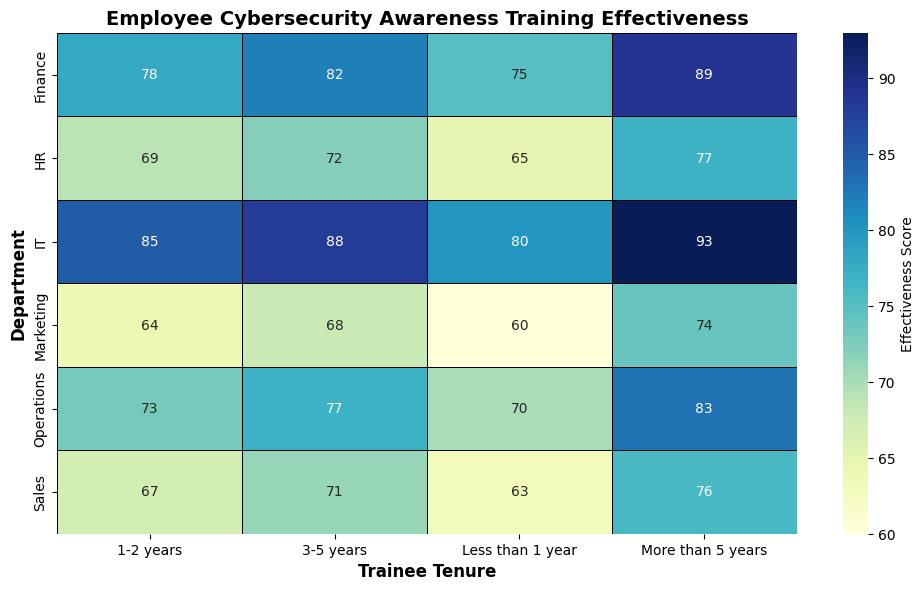Which department shows the highest overall effectiveness score? The highest overall effectiveness score is visible by identifying the darkest cell color in the chart. IT department employees with more than 5 years of tenure have the highest effectiveness score of 93.
Answer: IT What is the average effectiveness score for the HR department? To find the average effectiveness score for the HR department, sum the scores and divide by the number of scores: (65 + 69 + 72 + 77) / 4 = 283 / 4 = 70.75.
Answer: 70.75 How does the effectiveness score for less than 1-year trainees in Sales compare to those in Marketing? By comparing the cell colors and annotations, the effectiveness score for less than 1-year trainees in Sales is 63, and in Marketing, it is 60. Thus, the score is higher in Sales.
Answer: Sales (63) > Marketing (60) Which tenure level in the Operations department has the most significant increase in effectiveness compared to the previous tenure level? Observe the differences between consecutive tenure levels. The largest increase in the Operations department is from 3-5 years (77) to more than 5 years (83), an increase of 6 points.
Answer: More than 5 years Are there any departments with a uniform increase in scores as tenure increases? Look for a pattern where each consecutive tenure level has a higher score than the previous one. The IT and Finance departments show consistent increases across all tenure levels.
Answer: IT and Finance What is the total effectiveness score for all tenure levels in the Marketing department? Sum the effectiveness scores for each tenure level in the Marketing department: 60 + 64 + 68 + 74 = 266.
Answer: 266 Is there any department where the less than 1-year trainees score more than the 1-2 years trainees in any other department? Compare the effectiveness scores for less than 1-year trainees in all departments with the 1-2 years trainees in all other departments. IT less than 1 year (80) is higher than Operations 1-2 years (73).
Answer: Yes, IT vs Operations Which department shows the lowest effectiveness score across all tenure levels? Identify the lightest cell color in the chart. The marketing department has the lowest effectiveness score of 60 for less than 1-year trainees.
Answer: Marketing What is the combined effectiveness score for employees with more than 5 years of tenure in all departments? Sum the effectiveness scores for employees with more than 5 years of tenure across all departments: 89 (Finance) + 77 (HR) + 93 (IT) + 74 (Marketing) + 83 (Operations) + 76 (Sales) = 492.
Answer: 492 